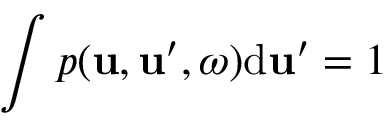Convert formula to latex. <formula><loc_0><loc_0><loc_500><loc_500>\int p ( u , u ^ { \prime } , \omega ) d u ^ { \prime } = 1</formula> 